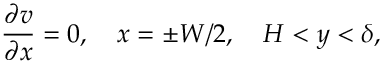<formula> <loc_0><loc_0><loc_500><loc_500>\frac { \partial v } { \partial x } = 0 , x = \pm W / 2 , H < y < \delta ,</formula> 